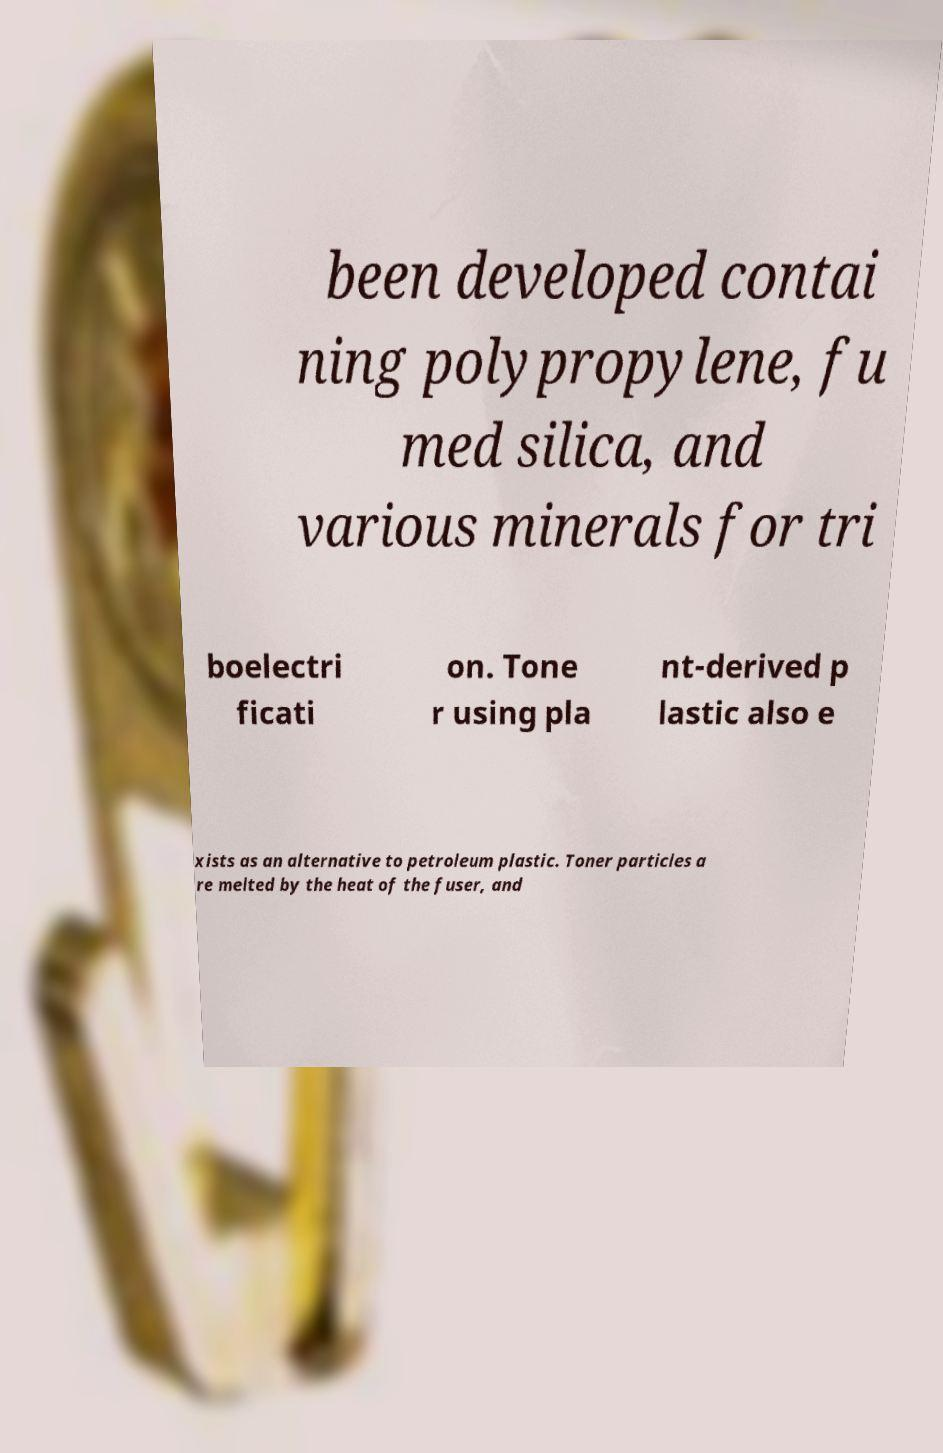Please identify and transcribe the text found in this image. been developed contai ning polypropylene, fu med silica, and various minerals for tri boelectri ficati on. Tone r using pla nt-derived p lastic also e xists as an alternative to petroleum plastic. Toner particles a re melted by the heat of the fuser, and 